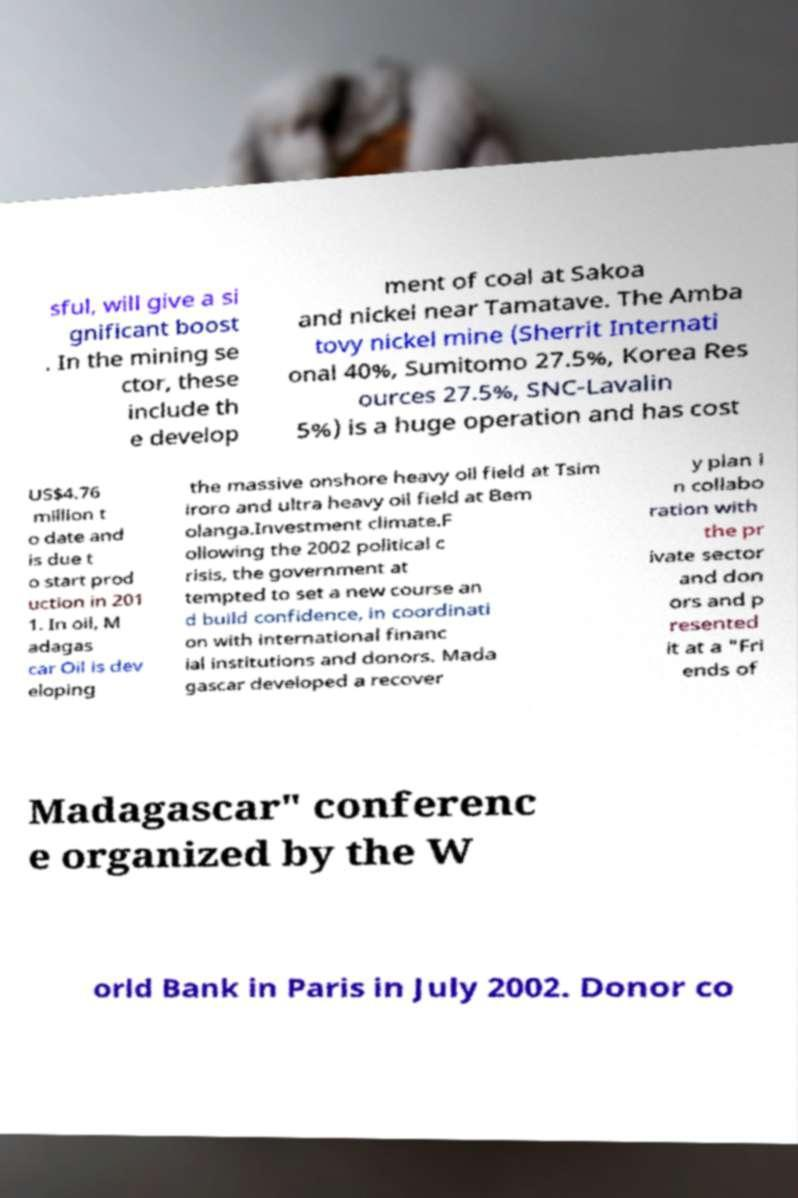Please identify and transcribe the text found in this image. sful, will give a si gnificant boost . In the mining se ctor, these include th e develop ment of coal at Sakoa and nickel near Tamatave. The Amba tovy nickel mine (Sherrit Internati onal 40%, Sumitomo 27.5%, Korea Res ources 27.5%, SNC-Lavalin 5%) is a huge operation and has cost US$4.76 million t o date and is due t o start prod uction in 201 1. In oil, M adagas car Oil is dev eloping the massive onshore heavy oil field at Tsim iroro and ultra heavy oil field at Bem olanga.Investment climate.F ollowing the 2002 political c risis, the government at tempted to set a new course an d build confidence, in coordinati on with international financ ial institutions and donors. Mada gascar developed a recover y plan i n collabo ration with the pr ivate sector and don ors and p resented it at a "Fri ends of Madagascar" conferenc e organized by the W orld Bank in Paris in July 2002. Donor co 